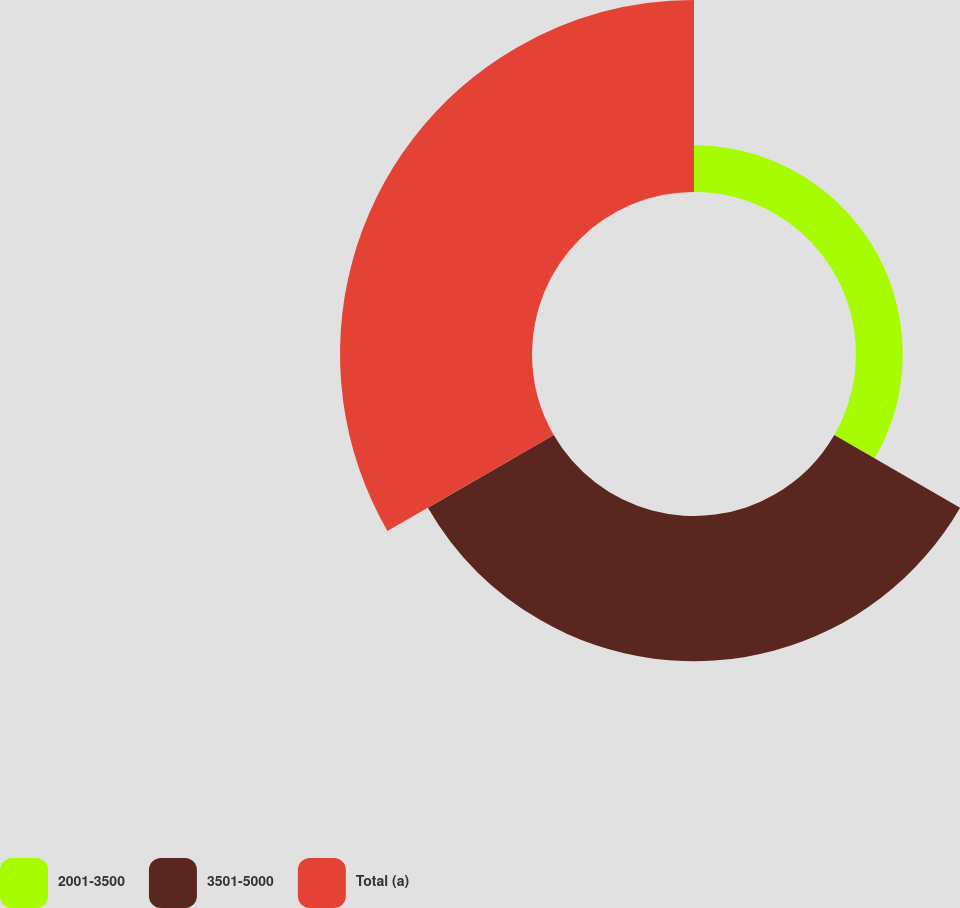Convert chart to OTSL. <chart><loc_0><loc_0><loc_500><loc_500><pie_chart><fcel>2001-3500<fcel>3501-5000<fcel>Total (a)<nl><fcel>12.17%<fcel>37.83%<fcel>50.0%<nl></chart> 